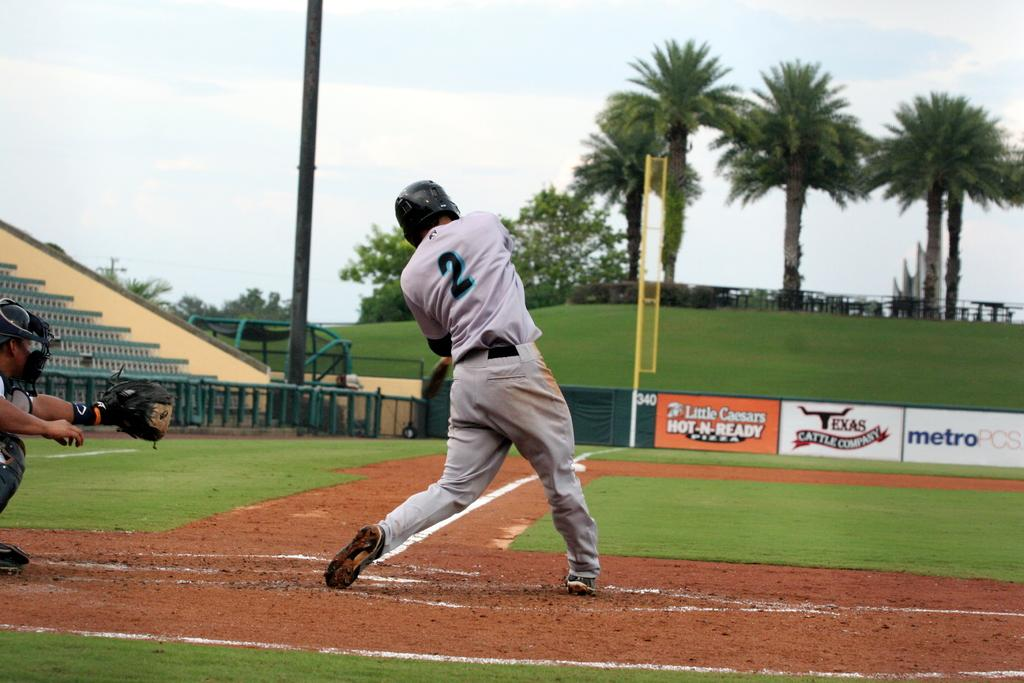Provide a one-sentence caption for the provided image. Player number 2 is at bat and taking a swing. 